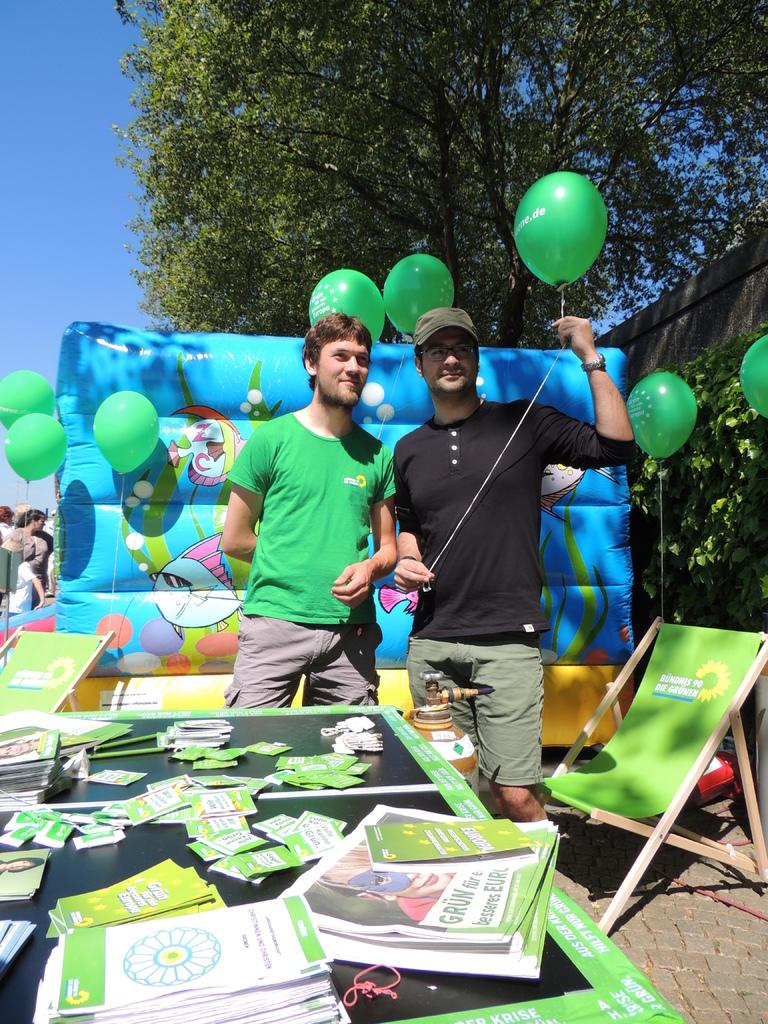How many people are in the image? There are two men in the image. What are the men holding in their hands? The men are holding balloons with strings. What can be seen in the background of the image? There is a tree visible in the background of the image. What is on the table in the image? Papers are present on the table. What type of furniture is in the image? There is a chair in the image. What is the rate of the cloud moving in the image? There is no cloud present in the image, so it is not possible to determine the rate at which it might be moving. What country is depicted in the image? The image does not depict a specific country; it features two men holding balloons with strings, a tree in the background, a table with papers, and a chair. 